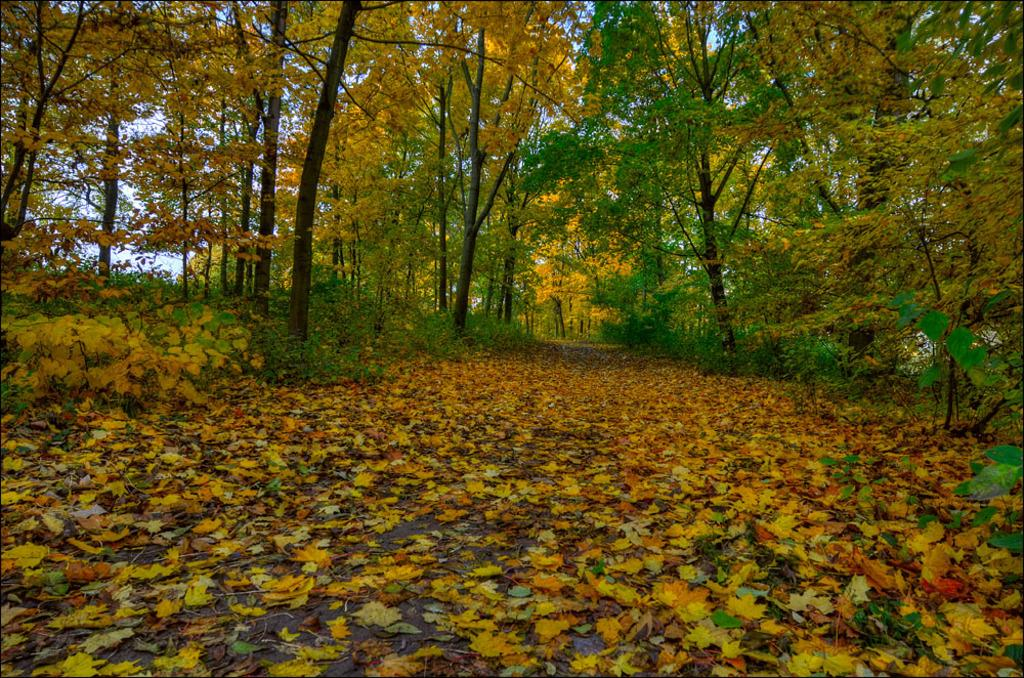What is covering the ground at the bottom of the image? There are many leaves on the ground at the bottom of the image. What can be seen in the background of the image? There are trees in the background of the image. What type of knowledge can be gained from studying the brain in the image? There is no brain present in the image, so no knowledge about the brain can be gained from studying it. 